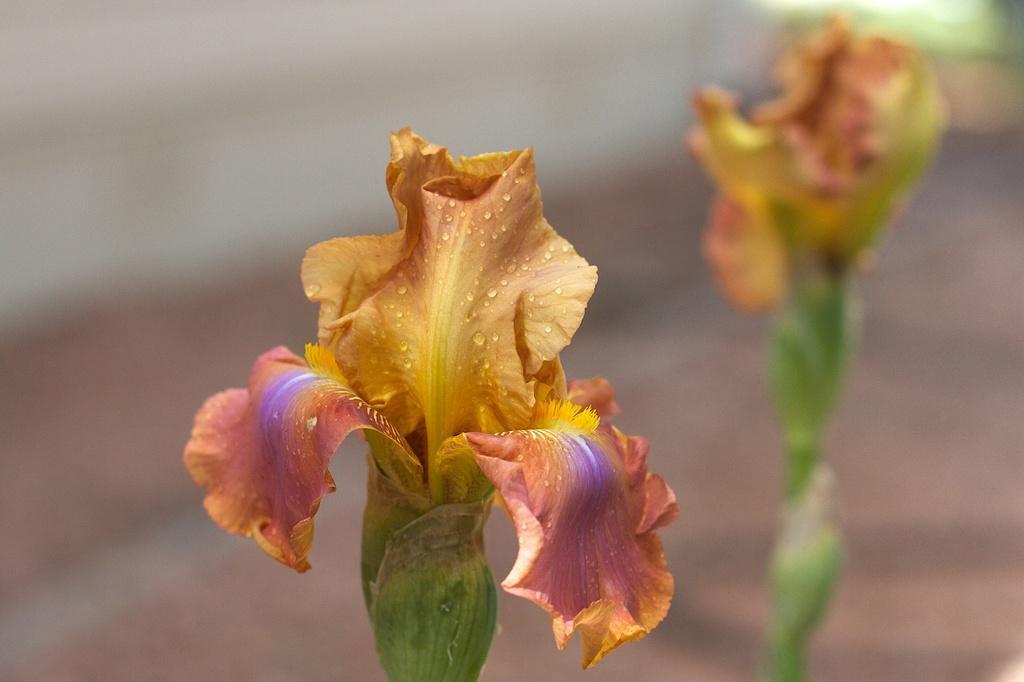Could you give a brief overview of what you see in this image? In this image I see a flower which is of orange, yellow, violet and pink in color and I see water droplets on it and in the background it is blurred and I see another flower over here. 